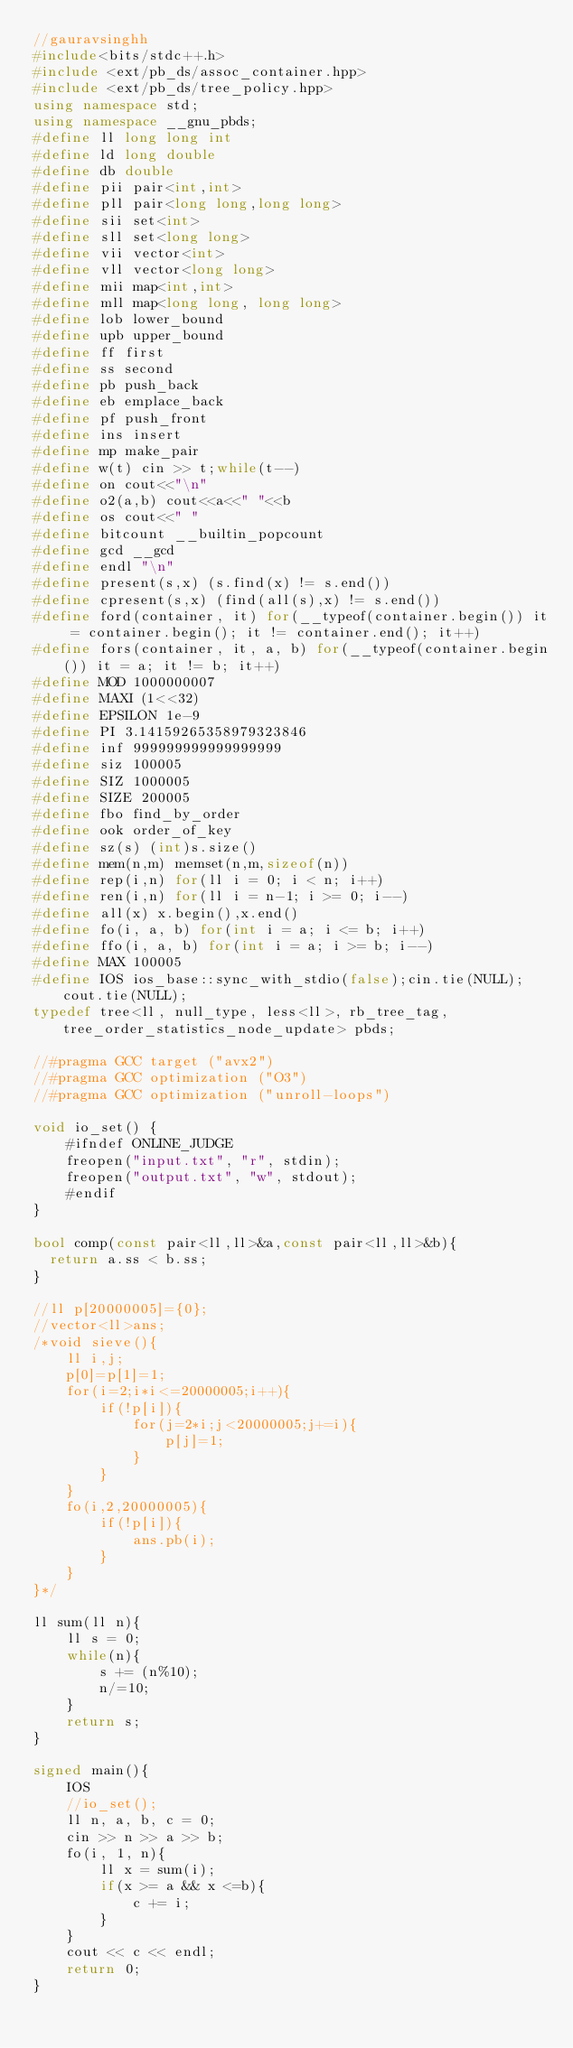Convert code to text. <code><loc_0><loc_0><loc_500><loc_500><_C++_>//gauravsinghh
#include<bits/stdc++.h>
#include <ext/pb_ds/assoc_container.hpp>
#include <ext/pb_ds/tree_policy.hpp>
using namespace std;
using namespace __gnu_pbds;
#define ll long long int
#define ld long double
#define db double
#define pii pair<int,int>
#define pll pair<long long,long long>
#define sii set<int>
#define sll set<long long>
#define vii vector<int> 
#define vll vector<long long>
#define mii map<int,int>
#define mll map<long long, long long>
#define lob lower_bound
#define upb upper_bound
#define ff first
#define ss second
#define pb push_back
#define eb emplace_back
#define pf push_front
#define ins insert
#define mp make_pair
#define w(t) cin >> t;while(t--)
#define on cout<<"\n"
#define o2(a,b) cout<<a<<" "<<b
#define os cout<<" "
#define bitcount __builtin_popcount
#define gcd __gcd
#define endl "\n"
#define present(s,x) (s.find(x) != s.end()) 
#define cpresent(s,x) (find(all(s),x) != s.end()) 
#define ford(container, it) for(__typeof(container.begin()) it = container.begin(); it != container.end(); it++) 
#define fors(container, it, a, b) for(__typeof(container.begin()) it = a; it != b; it++) 
#define MOD 1000000007
#define MAXI (1<<32)
#define EPSILON 1e-9
#define PI 3.14159265358979323846
#define inf 999999999999999999
#define siz 100005
#define SIZ 1000005
#define SIZE 200005
#define fbo find_by_order
#define ook order_of_key
#define sz(s) (int)s.size()
#define mem(n,m) memset(n,m,sizeof(n))
#define rep(i,n) for(ll i = 0; i < n; i++)
#define ren(i,n) for(ll i = n-1; i >= 0; i--)
#define all(x) x.begin(),x.end()
#define fo(i, a, b) for(int i = a; i <= b; i++)
#define ffo(i, a, b) for(int i = a; i >= b; i--)
#define MAX 100005
#define IOS ios_base::sync_with_stdio(false);cin.tie(NULL);cout.tie(NULL);
typedef tree<ll, null_type, less<ll>, rb_tree_tag, tree_order_statistics_node_update> pbds;

//#pragma GCC target ("avx2")
//#pragma GCC optimization ("O3")
//#pragma GCC optimization ("unroll-loops")

void io_set() {
    #ifndef ONLINE_JUDGE
    freopen("input.txt", "r", stdin);
    freopen("output.txt", "w", stdout);
    #endif
}

bool comp(const pair<ll,ll>&a,const pair<ll,ll>&b){
	return a.ss < b.ss;
}

//ll p[20000005]={0};
//vector<ll>ans;
/*void sieve(){
    ll i,j;
    p[0]=p[1]=1;
    for(i=2;i*i<=20000005;i++){
        if(!p[i]){
            for(j=2*i;j<20000005;j+=i){
                p[j]=1;
            }
        }
    }
    fo(i,2,20000005){
        if(!p[i]){
            ans.pb(i);
        }
    }
}*/

ll sum(ll n){
    ll s = 0;
    while(n){
        s += (n%10);
        n/=10;
    }
    return s;
}

signed main(){ 
    IOS
    //io_set();
    ll n, a, b, c = 0;
    cin >> n >> a >> b;
    fo(i, 1, n){
        ll x = sum(i);
        if(x >= a && x <=b){
            c += i;
        }
    }
    cout << c << endl;
    return 0;
}

</code> 